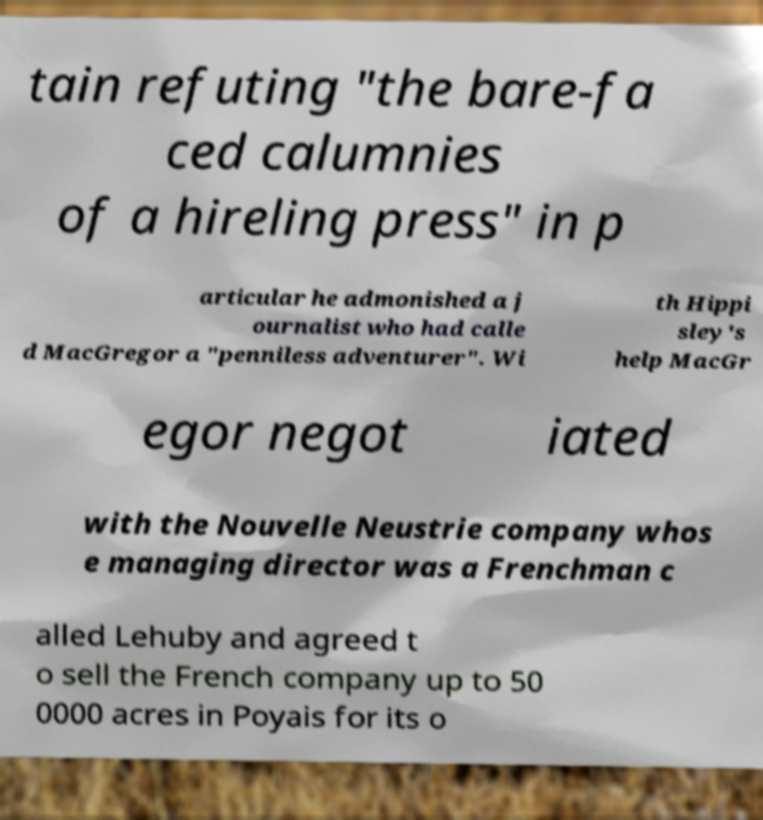There's text embedded in this image that I need extracted. Can you transcribe it verbatim? tain refuting "the bare-fa ced calumnies of a hireling press" in p articular he admonished a j ournalist who had calle d MacGregor a "penniless adventurer". Wi th Hippi sley's help MacGr egor negot iated with the Nouvelle Neustrie company whos e managing director was a Frenchman c alled Lehuby and agreed t o sell the French company up to 50 0000 acres in Poyais for its o 